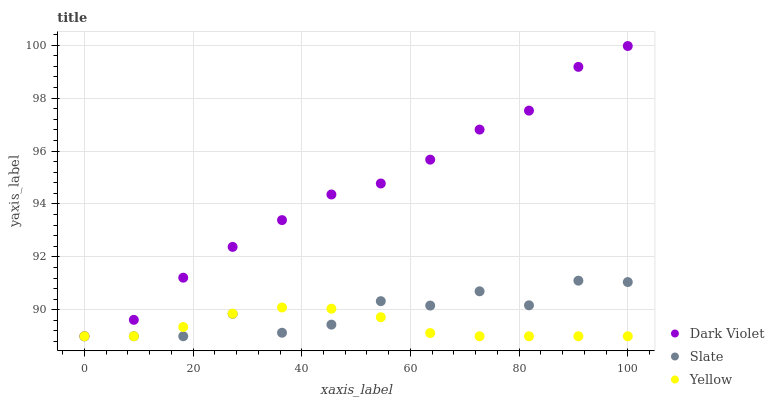Does Yellow have the minimum area under the curve?
Answer yes or no. Yes. Does Dark Violet have the maximum area under the curve?
Answer yes or no. Yes. Does Dark Violet have the minimum area under the curve?
Answer yes or no. No. Does Yellow have the maximum area under the curve?
Answer yes or no. No. Is Yellow the smoothest?
Answer yes or no. Yes. Is Slate the roughest?
Answer yes or no. Yes. Is Dark Violet the smoothest?
Answer yes or no. No. Is Dark Violet the roughest?
Answer yes or no. No. Does Slate have the lowest value?
Answer yes or no. Yes. Does Dark Violet have the highest value?
Answer yes or no. Yes. Does Yellow have the highest value?
Answer yes or no. No. Does Slate intersect Yellow?
Answer yes or no. Yes. Is Slate less than Yellow?
Answer yes or no. No. Is Slate greater than Yellow?
Answer yes or no. No. 